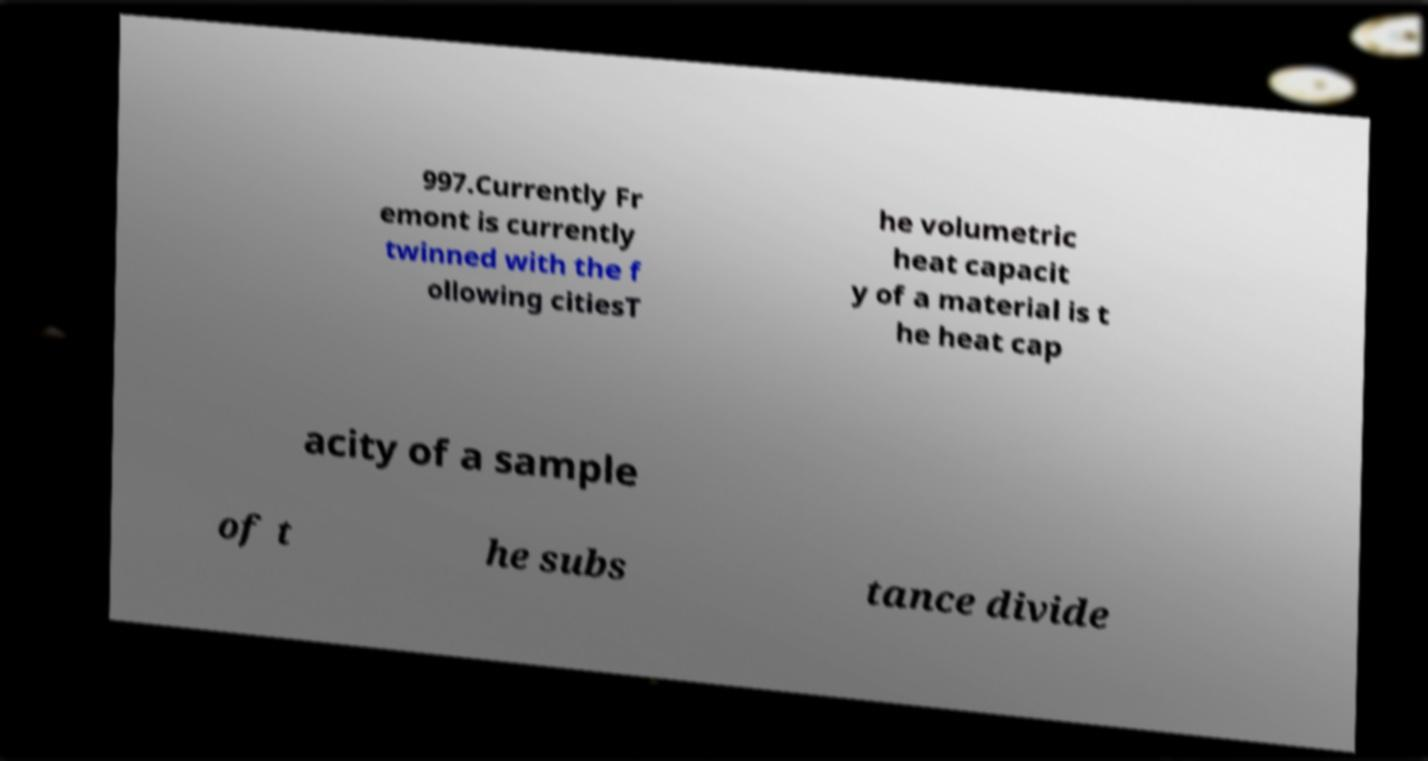Could you extract and type out the text from this image? 997.Currently Fr emont is currently twinned with the f ollowing citiesT he volumetric heat capacit y of a material is t he heat cap acity of a sample of t he subs tance divide 